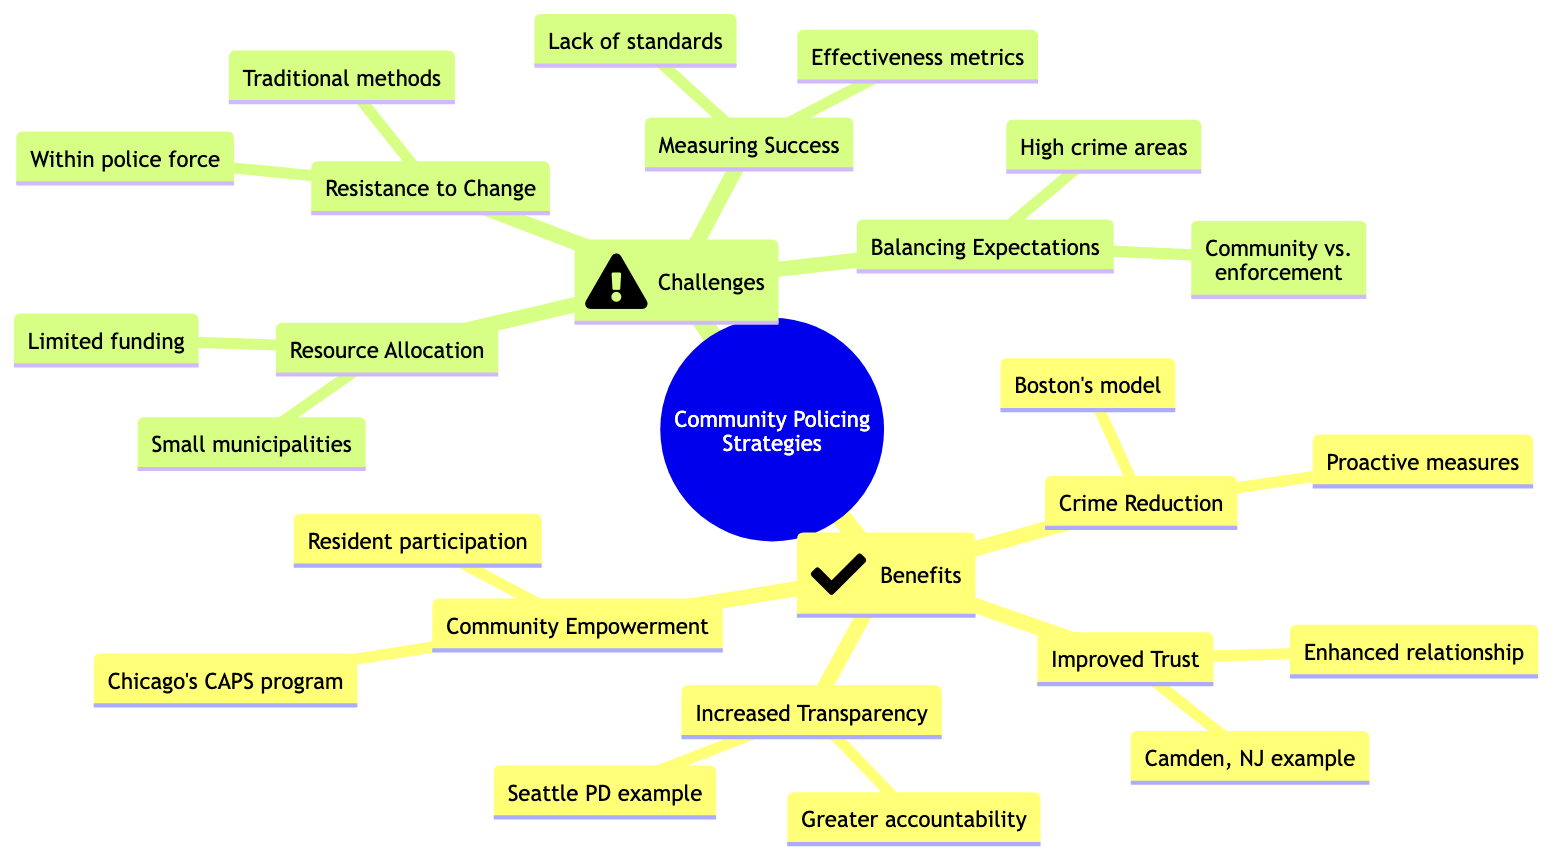What is one benefit of community policing related to the relationship between police and community? The benefit labeled "Improved Trust" indicates that it enhances the relationship between community and police.
Answer: Improved Trust Which city is mentioned as an example for rebuilding trust through community engagement? The diagram explicitly states Camden, NJ as an example in the "Improved Trust" section.
Answer: Camden, NJ How many challenges are listed in the mind map? There are four challenges identified under the "Challenges" node in the mind map.
Answer: 4 What strategy is mentioned for balancing community needs and law enforcement priorities? The mind map lists "Balancing Expectations" as the strategy to address this issue.
Answer: Balancing Expectations What is a challenge related to the police force mentioned in the diagram? "Resistance to Change" specifically refers to resistance from within the police force.
Answer: Resistance to Change What does the term "Measuring Success" refer to in the context of the diagram? "Measuring Success" is a challenge referring to the difficulties in assessing the effectiveness of community policing efforts.
Answer: Measuring Success Which program is cited as an example for empowering residents to participate in safety initiatives? The diagram refers to Chicago's CAPS program as an example under the "Community Empowerment" section.
Answer: Chicago's CAPS program What type of policing does the "Boston's model" refer to? The "Boston's model" under the "Crime Reduction" section refers to community policing that decreases youth violence.
Answer: Community policing What is an example of a challenge due to limited resources? The challenge "Resource Allocation" specifically highlights limited funding for community policing programs.
Answer: Limited funding 